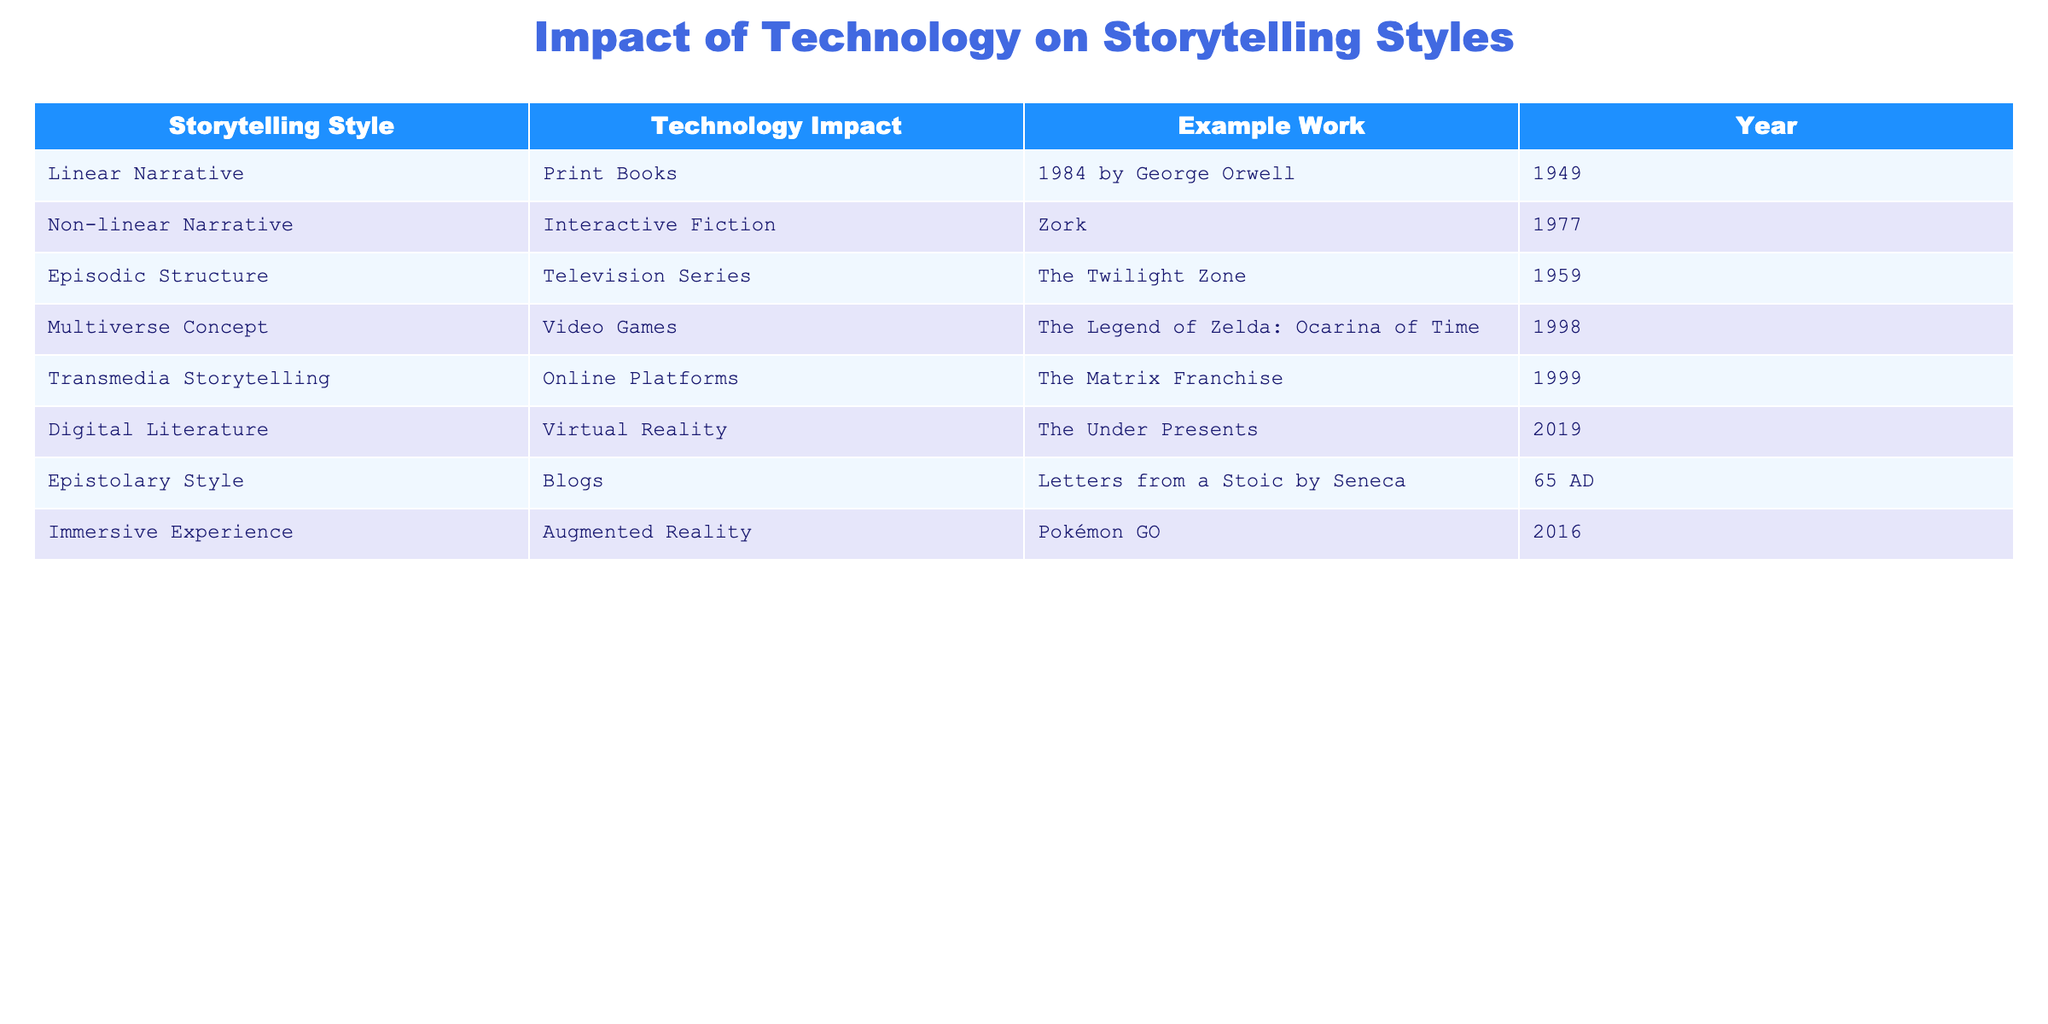What storytelling style is associated with the technology of Print Books? The "Print Books" technology is linked to the "Linear Narrative" storytelling style in the table. By looking directly at the corresponding row for Print Books, we see that it aligns with Linear Narrative.
Answer: Linear Narrative Which year saw the release of "Zork" and how does it relate to its storytelling style? "Zork" was released in 1977 and is related to the "Non-linear Narrative" storytelling style. This can be found by identifying the row that lists Zork and checking its associated storytelling style in the table.
Answer: 1977, Non-linear Narrative What is the most recent work listed in the table and which storytelling style does it represent? The most recent work in the table is "The Under Presents," released in 2019. It represents the "Digital Literature" storytelling style. This is determined by checking the release years listed and identifying the latest one.
Answer: The Under Presents, Digital Literature True or false: "The Matrix Franchise" is an example of Linear Narrative storytelling style. This statement is false. In the table, "The Matrix Franchise," associated with "Transmedia Storytelling," does not correspond to Linear Narrative. By checking the table's content, we can verify the storytelling style matched to The Matrix Franchise.
Answer: False If we consider the technologies related to immersive experiences, how many different storytelling styles are represented in the table? There are two storytelling styles associated with immersive experiences. "Digital Literature" ties to Virtual Reality, and "Immersive Experience" associates with Augmented Reality. Thus, by reviewing the rows for related technologies, we see two distinct styles present.
Answer: 2 Which storytelling style has the earliest example in the table? The earliest example is "Letters from a Stoic" by Seneca in the "Epistolary Style." This can be found by looking at the years listed, where 65 AD is the oldest and cross-referencing with the storytelling style provided in that row.
Answer: Epistolary Style Is there any technology listed in the table that utilizes blogs as its storytelling medium? Yes, the technology associated with blogs is "Blogs," linked to the storytelling style "Epistolary Style." This is confirmed by locating the specific row in the table that mentions blogs and its corresponding storytelling style.
Answer: Yes How many works listed in the table relate to video games? There is one work in the table related to video games, which is "The Legend of Zelda: Ocarina of Time," associated with the "Multiverse Concept." This is discerned by counting the relevant rows that mention video games and identifying that only one instance appears.
Answer: 1 What is the common factor between "Pokémon GO" and "Zork" regarding their storytelling styles? Both "Pokémon GO" and "Zork" utilize technology to create a unique storytelling experience, with "Pokémon GO" relating to "Immersive Experience" through Augmented Reality and "Zork" connecting with "Non-linear Narrative" through Interactive Fiction. The relationship is established by examining their respective technologies and storytelling styles side-by-side.
Answer: They both use technology to enhance the storytelling experience 